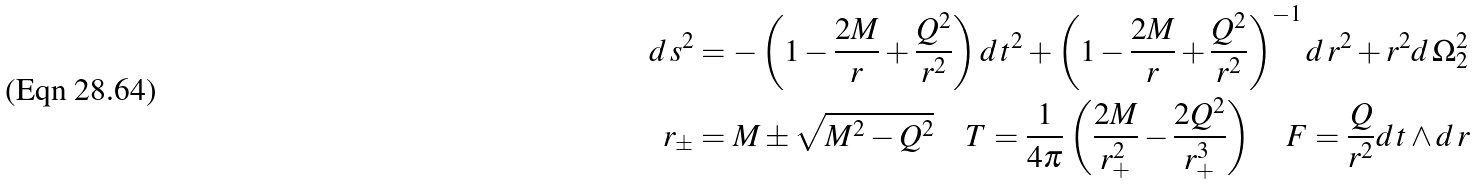Convert formula to latex. <formula><loc_0><loc_0><loc_500><loc_500>d \, s ^ { 2 } & = - \left ( 1 - \frac { 2 M } { r } + \frac { Q ^ { 2 } } { r ^ { 2 } } \right ) d \, t ^ { 2 } + \left ( 1 - \frac { 2 M } { r } + \frac { Q ^ { 2 } } { r ^ { 2 } } \right ) ^ { - 1 } d \, r ^ { 2 } + r ^ { 2 } d \, \Omega _ { 2 } ^ { 2 } \\ r _ { \pm } & = M \pm \sqrt { M ^ { 2 } - Q ^ { 2 } } \quad T = \frac { 1 } { 4 \pi } \left ( \frac { 2 M } { r _ { + } ^ { 2 } } - \frac { 2 Q ^ { 2 } } { r _ { + } ^ { 3 } } \right ) \quad F = \frac { Q } { r ^ { 2 } } d \, t \wedge d \, r</formula> 